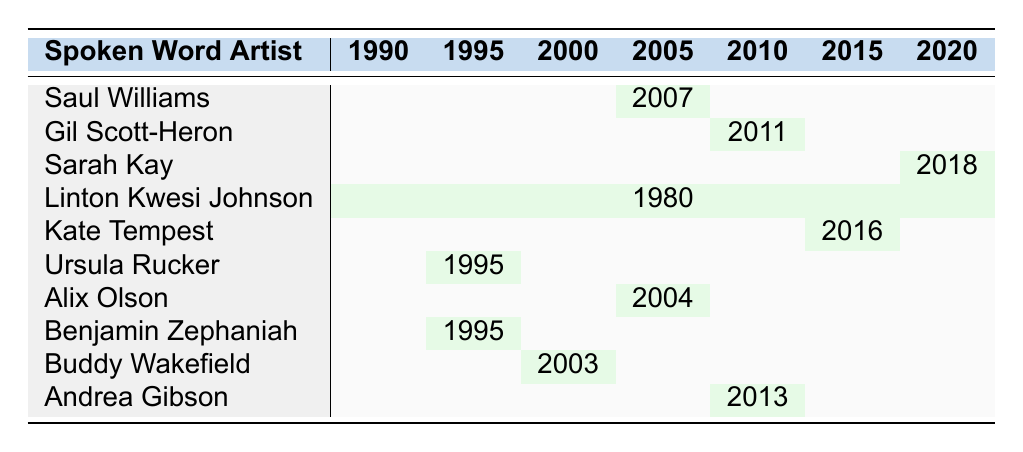What year did Saul Williams collaborate with Trent Reznor? By locating the row for Saul Williams and examining the year associated with his collaboration with Trent Reznor, which is shown in the 2007 cell, we find that the collaboration took place in 2007.
Answer: 2007 Did any spoken word artists collaborate with musicians in 1995? Referring to the table, both Ursula Rucker and Benjamin Zephaniah have collaborations listed in the year 1995, confirming that there were collaborations that year.
Answer: Yes How many collaborations occurred between 2000 and 2010? Looking across the years from 2000 to 2010, I can identify the following collaborations: 2003 (Buddy Wakefield), 2004 (Alix Olson), 2007 (Saul Williams), and 2011 (Gil Scott-Heron). Hence, there are 4 collaborations in total during this period.
Answer: 4 Is there any collaboration listed for the year 2000? Checking the table, there is no cell filled for the year 2000, indicating no collaborations were reported for that year.
Answer: No Which artist collaborated in 2016 and with whom? I can observe the entry for 2016, which is linked to Kate Tempest, who collaborated with Dan Carey. This presents a direct partner collaboration for that year.
Answer: Kate Tempest with Dan Carey What is the latest collaboration year in the data? By scanning the collaboration years listed, the most recent year mentioned is 2018, which corresponds to Sarah Kay's collaboration.
Answer: 2018 How many spoken word artists collaborated with musicians in the 2000s (2000-2009)? Reviewing the table for the decade of the 2000s, there are three known collaborations: 2003 (Buddy Wakefield), 2004 (Alix Olson), and 2007 (Saul Williams), so there were 3 artists who collaborated during this decade.
Answer: 3 Which spoken word artist had a project named "We're New Here"? Upon checking the table, I see that Gil Scott-Heron collaborated with Jamie xx on the project titled "We're New Here" in the year 2011.
Answer: Gil Scott-Heron Were there any collaborations by Linton Kwesi Johnson in the 1990s? Looking specifically at Linton Kwesi Johnson, his collaboration is noted in 1980, with no entries between 1990 and 1999, indicating no collaborations from him in that decade.
Answer: No What project did Alix Olson work on and in what year? By examining Alix Olson's entry, I find that she collaborated on the project "Independence Day" in the year 2004, giving specifics about her work during that time.
Answer: Independence Day in 2004 